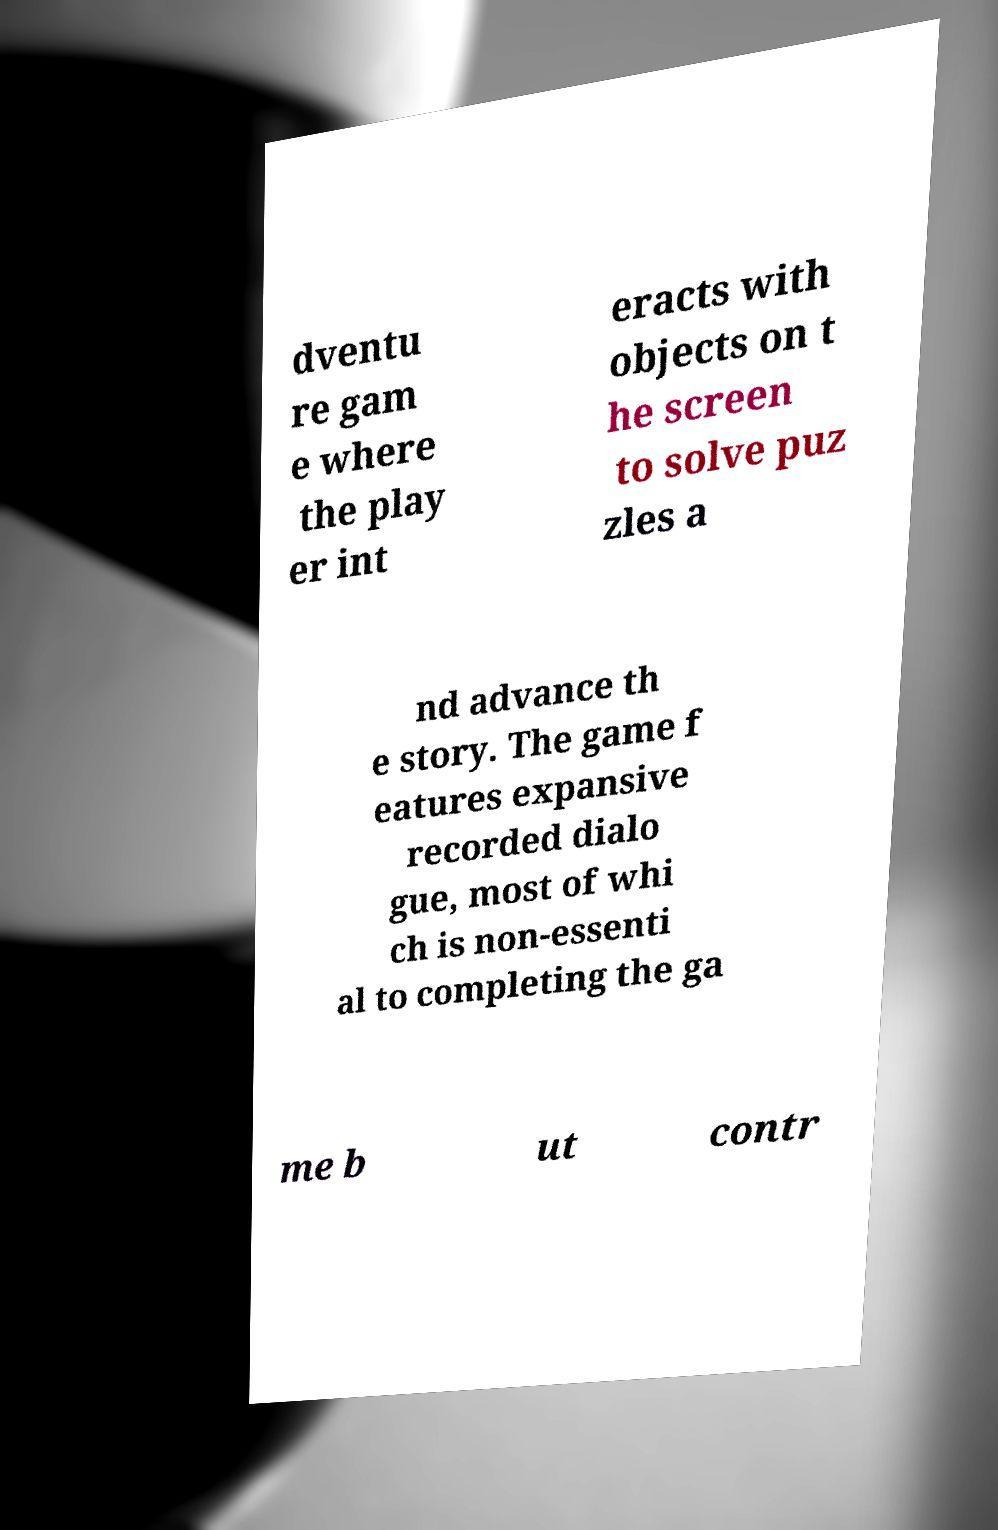For documentation purposes, I need the text within this image transcribed. Could you provide that? dventu re gam e where the play er int eracts with objects on t he screen to solve puz zles a nd advance th e story. The game f eatures expansive recorded dialo gue, most of whi ch is non-essenti al to completing the ga me b ut contr 